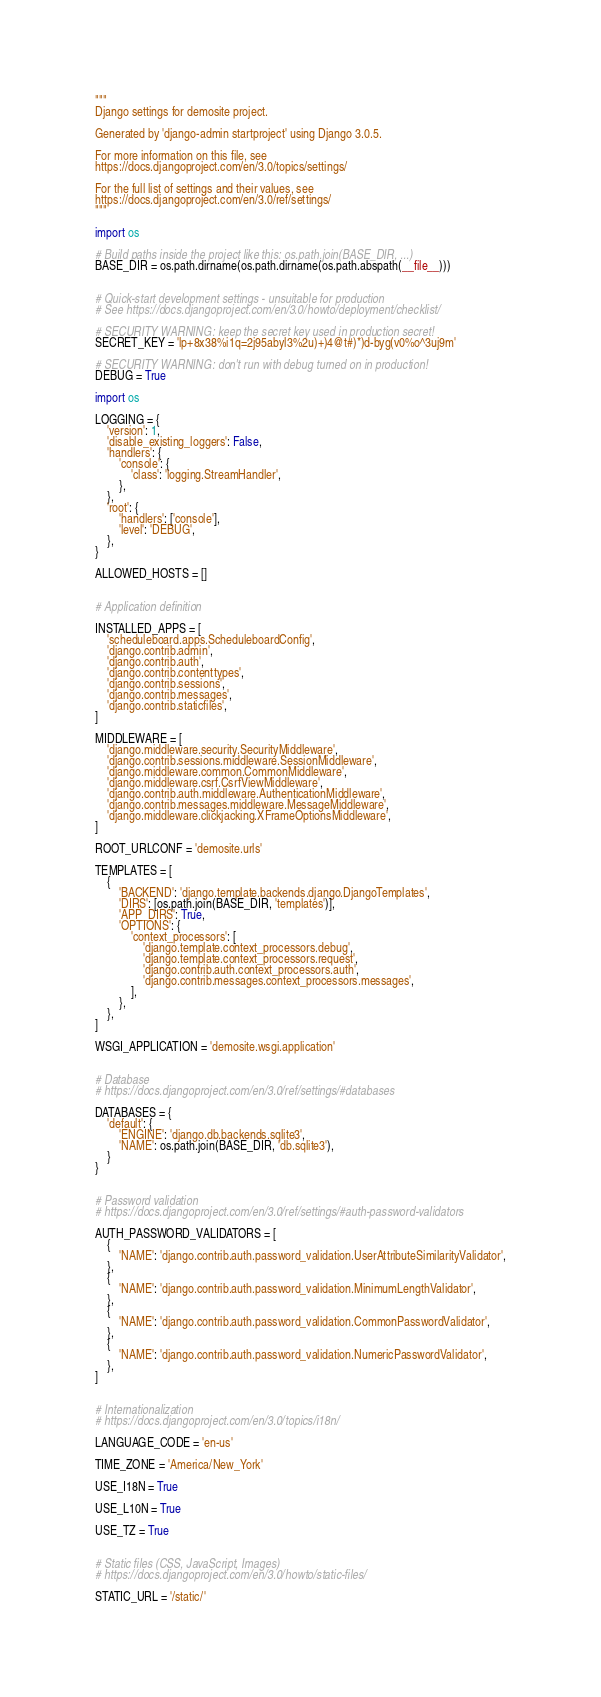<code> <loc_0><loc_0><loc_500><loc_500><_Python_>"""
Django settings for demosite project.

Generated by 'django-admin startproject' using Django 3.0.5.

For more information on this file, see
https://docs.djangoproject.com/en/3.0/topics/settings/

For the full list of settings and their values, see
https://docs.djangoproject.com/en/3.0/ref/settings/
"""

import os

# Build paths inside the project like this: os.path.join(BASE_DIR, ...)
BASE_DIR = os.path.dirname(os.path.dirname(os.path.abspath(__file__)))


# Quick-start development settings - unsuitable for production
# See https://docs.djangoproject.com/en/3.0/howto/deployment/checklist/

# SECURITY WARNING: keep the secret key used in production secret!
SECRET_KEY = 'lp+8x38%i1q=2j95abyl3%2u)+)4@t#)*)d-byg(v0%o^3uj9m'

# SECURITY WARNING: don't run with debug turned on in production!
DEBUG = True

import os

LOGGING = {
    'version': 1,
    'disable_existing_loggers': False,
    'handlers': {
        'console': {
            'class': 'logging.StreamHandler',
        },
    },
    'root': {
        'handlers': ['console'],
        'level': 'DEBUG',
    },
}

ALLOWED_HOSTS = []


# Application definition

INSTALLED_APPS = [
    'scheduleboard.apps.ScheduleboardConfig',
    'django.contrib.admin',
    'django.contrib.auth',
    'django.contrib.contenttypes',
    'django.contrib.sessions',
    'django.contrib.messages',
    'django.contrib.staticfiles',
]

MIDDLEWARE = [
    'django.middleware.security.SecurityMiddleware',
    'django.contrib.sessions.middleware.SessionMiddleware',
    'django.middleware.common.CommonMiddleware',
    'django.middleware.csrf.CsrfViewMiddleware',
    'django.contrib.auth.middleware.AuthenticationMiddleware',
    'django.contrib.messages.middleware.MessageMiddleware',
    'django.middleware.clickjacking.XFrameOptionsMiddleware',
]

ROOT_URLCONF = 'demosite.urls'

TEMPLATES = [
    {
        'BACKEND': 'django.template.backends.django.DjangoTemplates',
        'DIRS': [os.path.join(BASE_DIR, 'templates')],
        'APP_DIRS': True,
        'OPTIONS': {
            'context_processors': [
                'django.template.context_processors.debug',
                'django.template.context_processors.request',
                'django.contrib.auth.context_processors.auth',
                'django.contrib.messages.context_processors.messages',
            ],
        },
    },
]

WSGI_APPLICATION = 'demosite.wsgi.application'


# Database
# https://docs.djangoproject.com/en/3.0/ref/settings/#databases

DATABASES = {
    'default': {
        'ENGINE': 'django.db.backends.sqlite3',
        'NAME': os.path.join(BASE_DIR, 'db.sqlite3'),
    }
}


# Password validation
# https://docs.djangoproject.com/en/3.0/ref/settings/#auth-password-validators

AUTH_PASSWORD_VALIDATORS = [
    {
        'NAME': 'django.contrib.auth.password_validation.UserAttributeSimilarityValidator',
    },
    {
        'NAME': 'django.contrib.auth.password_validation.MinimumLengthValidator',
    },
    {
        'NAME': 'django.contrib.auth.password_validation.CommonPasswordValidator',
    },
    {
        'NAME': 'django.contrib.auth.password_validation.NumericPasswordValidator',
    },
]


# Internationalization
# https://docs.djangoproject.com/en/3.0/topics/i18n/

LANGUAGE_CODE = 'en-us'

TIME_ZONE = 'America/New_York'

USE_I18N = True

USE_L10N = True

USE_TZ = True


# Static files (CSS, JavaScript, Images)
# https://docs.djangoproject.com/en/3.0/howto/static-files/

STATIC_URL = '/static/'
</code> 